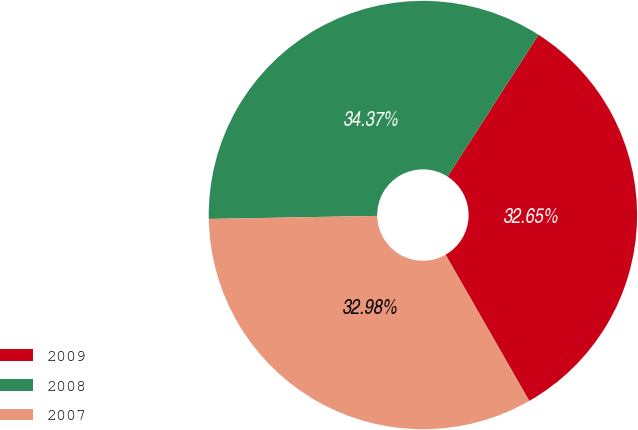Convert chart. <chart><loc_0><loc_0><loc_500><loc_500><pie_chart><fcel>2009<fcel>2008<fcel>2007<nl><fcel>32.65%<fcel>34.37%<fcel>32.98%<nl></chart> 